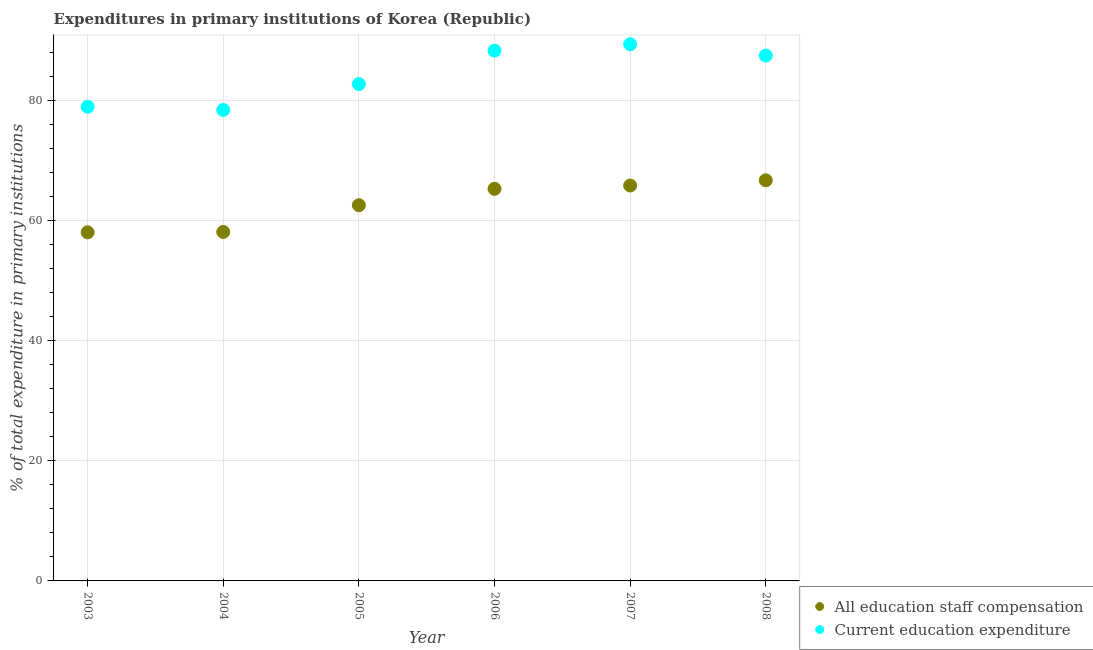What is the expenditure in education in 2006?
Your answer should be compact. 88.3. Across all years, what is the maximum expenditure in staff compensation?
Make the answer very short. 66.71. Across all years, what is the minimum expenditure in education?
Give a very brief answer. 78.43. In which year was the expenditure in staff compensation maximum?
Ensure brevity in your answer.  2008. What is the total expenditure in staff compensation in the graph?
Give a very brief answer. 376.55. What is the difference between the expenditure in staff compensation in 2005 and that in 2008?
Make the answer very short. -4.15. What is the difference between the expenditure in staff compensation in 2005 and the expenditure in education in 2008?
Give a very brief answer. -24.93. What is the average expenditure in staff compensation per year?
Ensure brevity in your answer.  62.76. In the year 2008, what is the difference between the expenditure in education and expenditure in staff compensation?
Your answer should be compact. 20.78. In how many years, is the expenditure in staff compensation greater than 12 %?
Offer a terse response. 6. What is the ratio of the expenditure in education in 2004 to that in 2007?
Your answer should be compact. 0.88. Is the expenditure in staff compensation in 2007 less than that in 2008?
Ensure brevity in your answer.  Yes. What is the difference between the highest and the second highest expenditure in staff compensation?
Provide a short and direct response. 0.87. What is the difference between the highest and the lowest expenditure in staff compensation?
Offer a terse response. 8.66. In how many years, is the expenditure in education greater than the average expenditure in education taken over all years?
Your answer should be very brief. 3. How many years are there in the graph?
Your answer should be very brief. 6. Does the graph contain any zero values?
Keep it short and to the point. No. How many legend labels are there?
Provide a succinct answer. 2. How are the legend labels stacked?
Your answer should be compact. Vertical. What is the title of the graph?
Offer a very short reply. Expenditures in primary institutions of Korea (Republic). What is the label or title of the X-axis?
Provide a short and direct response. Year. What is the label or title of the Y-axis?
Offer a very short reply. % of total expenditure in primary institutions. What is the % of total expenditure in primary institutions in All education staff compensation in 2003?
Your response must be concise. 58.05. What is the % of total expenditure in primary institutions of Current education expenditure in 2003?
Provide a succinct answer. 78.96. What is the % of total expenditure in primary institutions of All education staff compensation in 2004?
Your answer should be very brief. 58.11. What is the % of total expenditure in primary institutions in Current education expenditure in 2004?
Provide a succinct answer. 78.43. What is the % of total expenditure in primary institutions in All education staff compensation in 2005?
Offer a very short reply. 62.56. What is the % of total expenditure in primary institutions of Current education expenditure in 2005?
Your answer should be compact. 82.73. What is the % of total expenditure in primary institutions in All education staff compensation in 2006?
Your response must be concise. 65.29. What is the % of total expenditure in primary institutions in Current education expenditure in 2006?
Ensure brevity in your answer.  88.3. What is the % of total expenditure in primary institutions in All education staff compensation in 2007?
Ensure brevity in your answer.  65.84. What is the % of total expenditure in primary institutions of Current education expenditure in 2007?
Your answer should be very brief. 89.36. What is the % of total expenditure in primary institutions of All education staff compensation in 2008?
Provide a short and direct response. 66.71. What is the % of total expenditure in primary institutions of Current education expenditure in 2008?
Your answer should be very brief. 87.49. Across all years, what is the maximum % of total expenditure in primary institutions in All education staff compensation?
Your answer should be very brief. 66.71. Across all years, what is the maximum % of total expenditure in primary institutions in Current education expenditure?
Offer a very short reply. 89.36. Across all years, what is the minimum % of total expenditure in primary institutions in All education staff compensation?
Give a very brief answer. 58.05. Across all years, what is the minimum % of total expenditure in primary institutions of Current education expenditure?
Offer a terse response. 78.43. What is the total % of total expenditure in primary institutions in All education staff compensation in the graph?
Provide a succinct answer. 376.55. What is the total % of total expenditure in primary institutions in Current education expenditure in the graph?
Offer a terse response. 505.28. What is the difference between the % of total expenditure in primary institutions in All education staff compensation in 2003 and that in 2004?
Your answer should be compact. -0.06. What is the difference between the % of total expenditure in primary institutions of Current education expenditure in 2003 and that in 2004?
Make the answer very short. 0.53. What is the difference between the % of total expenditure in primary institutions of All education staff compensation in 2003 and that in 2005?
Provide a short and direct response. -4.51. What is the difference between the % of total expenditure in primary institutions in Current education expenditure in 2003 and that in 2005?
Offer a very short reply. -3.77. What is the difference between the % of total expenditure in primary institutions of All education staff compensation in 2003 and that in 2006?
Offer a terse response. -7.24. What is the difference between the % of total expenditure in primary institutions of Current education expenditure in 2003 and that in 2006?
Offer a very short reply. -9.34. What is the difference between the % of total expenditure in primary institutions in All education staff compensation in 2003 and that in 2007?
Provide a short and direct response. -7.79. What is the difference between the % of total expenditure in primary institutions of Current education expenditure in 2003 and that in 2007?
Give a very brief answer. -10.4. What is the difference between the % of total expenditure in primary institutions of All education staff compensation in 2003 and that in 2008?
Provide a short and direct response. -8.66. What is the difference between the % of total expenditure in primary institutions in Current education expenditure in 2003 and that in 2008?
Provide a short and direct response. -8.52. What is the difference between the % of total expenditure in primary institutions of All education staff compensation in 2004 and that in 2005?
Keep it short and to the point. -4.45. What is the difference between the % of total expenditure in primary institutions of Current education expenditure in 2004 and that in 2005?
Offer a terse response. -4.3. What is the difference between the % of total expenditure in primary institutions of All education staff compensation in 2004 and that in 2006?
Ensure brevity in your answer.  -7.18. What is the difference between the % of total expenditure in primary institutions of Current education expenditure in 2004 and that in 2006?
Offer a terse response. -9.87. What is the difference between the % of total expenditure in primary institutions in All education staff compensation in 2004 and that in 2007?
Give a very brief answer. -7.73. What is the difference between the % of total expenditure in primary institutions of Current education expenditure in 2004 and that in 2007?
Offer a very short reply. -10.93. What is the difference between the % of total expenditure in primary institutions of All education staff compensation in 2004 and that in 2008?
Your answer should be compact. -8.6. What is the difference between the % of total expenditure in primary institutions in Current education expenditure in 2004 and that in 2008?
Your answer should be very brief. -9.05. What is the difference between the % of total expenditure in primary institutions in All education staff compensation in 2005 and that in 2006?
Provide a succinct answer. -2.73. What is the difference between the % of total expenditure in primary institutions of Current education expenditure in 2005 and that in 2006?
Keep it short and to the point. -5.57. What is the difference between the % of total expenditure in primary institutions of All education staff compensation in 2005 and that in 2007?
Provide a short and direct response. -3.28. What is the difference between the % of total expenditure in primary institutions in Current education expenditure in 2005 and that in 2007?
Offer a terse response. -6.62. What is the difference between the % of total expenditure in primary institutions in All education staff compensation in 2005 and that in 2008?
Provide a short and direct response. -4.15. What is the difference between the % of total expenditure in primary institutions of Current education expenditure in 2005 and that in 2008?
Ensure brevity in your answer.  -4.75. What is the difference between the % of total expenditure in primary institutions in All education staff compensation in 2006 and that in 2007?
Give a very brief answer. -0.55. What is the difference between the % of total expenditure in primary institutions in Current education expenditure in 2006 and that in 2007?
Offer a very short reply. -1.06. What is the difference between the % of total expenditure in primary institutions of All education staff compensation in 2006 and that in 2008?
Your answer should be very brief. -1.42. What is the difference between the % of total expenditure in primary institutions of Current education expenditure in 2006 and that in 2008?
Offer a terse response. 0.82. What is the difference between the % of total expenditure in primary institutions in All education staff compensation in 2007 and that in 2008?
Offer a very short reply. -0.87. What is the difference between the % of total expenditure in primary institutions in Current education expenditure in 2007 and that in 2008?
Your answer should be compact. 1.87. What is the difference between the % of total expenditure in primary institutions of All education staff compensation in 2003 and the % of total expenditure in primary institutions of Current education expenditure in 2004?
Offer a terse response. -20.39. What is the difference between the % of total expenditure in primary institutions of All education staff compensation in 2003 and the % of total expenditure in primary institutions of Current education expenditure in 2005?
Give a very brief answer. -24.69. What is the difference between the % of total expenditure in primary institutions in All education staff compensation in 2003 and the % of total expenditure in primary institutions in Current education expenditure in 2006?
Make the answer very short. -30.25. What is the difference between the % of total expenditure in primary institutions in All education staff compensation in 2003 and the % of total expenditure in primary institutions in Current education expenditure in 2007?
Provide a short and direct response. -31.31. What is the difference between the % of total expenditure in primary institutions in All education staff compensation in 2003 and the % of total expenditure in primary institutions in Current education expenditure in 2008?
Keep it short and to the point. -29.44. What is the difference between the % of total expenditure in primary institutions in All education staff compensation in 2004 and the % of total expenditure in primary institutions in Current education expenditure in 2005?
Provide a succinct answer. -24.63. What is the difference between the % of total expenditure in primary institutions of All education staff compensation in 2004 and the % of total expenditure in primary institutions of Current education expenditure in 2006?
Keep it short and to the point. -30.2. What is the difference between the % of total expenditure in primary institutions of All education staff compensation in 2004 and the % of total expenditure in primary institutions of Current education expenditure in 2007?
Provide a succinct answer. -31.25. What is the difference between the % of total expenditure in primary institutions in All education staff compensation in 2004 and the % of total expenditure in primary institutions in Current education expenditure in 2008?
Provide a succinct answer. -29.38. What is the difference between the % of total expenditure in primary institutions of All education staff compensation in 2005 and the % of total expenditure in primary institutions of Current education expenditure in 2006?
Your answer should be compact. -25.74. What is the difference between the % of total expenditure in primary institutions in All education staff compensation in 2005 and the % of total expenditure in primary institutions in Current education expenditure in 2007?
Keep it short and to the point. -26.8. What is the difference between the % of total expenditure in primary institutions in All education staff compensation in 2005 and the % of total expenditure in primary institutions in Current education expenditure in 2008?
Offer a terse response. -24.93. What is the difference between the % of total expenditure in primary institutions in All education staff compensation in 2006 and the % of total expenditure in primary institutions in Current education expenditure in 2007?
Ensure brevity in your answer.  -24.07. What is the difference between the % of total expenditure in primary institutions of All education staff compensation in 2006 and the % of total expenditure in primary institutions of Current education expenditure in 2008?
Offer a terse response. -22.2. What is the difference between the % of total expenditure in primary institutions of All education staff compensation in 2007 and the % of total expenditure in primary institutions of Current education expenditure in 2008?
Give a very brief answer. -21.65. What is the average % of total expenditure in primary institutions of All education staff compensation per year?
Provide a short and direct response. 62.76. What is the average % of total expenditure in primary institutions in Current education expenditure per year?
Offer a very short reply. 84.21. In the year 2003, what is the difference between the % of total expenditure in primary institutions in All education staff compensation and % of total expenditure in primary institutions in Current education expenditure?
Your answer should be very brief. -20.91. In the year 2004, what is the difference between the % of total expenditure in primary institutions of All education staff compensation and % of total expenditure in primary institutions of Current education expenditure?
Your answer should be very brief. -20.33. In the year 2005, what is the difference between the % of total expenditure in primary institutions of All education staff compensation and % of total expenditure in primary institutions of Current education expenditure?
Keep it short and to the point. -20.18. In the year 2006, what is the difference between the % of total expenditure in primary institutions of All education staff compensation and % of total expenditure in primary institutions of Current education expenditure?
Ensure brevity in your answer.  -23.01. In the year 2007, what is the difference between the % of total expenditure in primary institutions of All education staff compensation and % of total expenditure in primary institutions of Current education expenditure?
Offer a very short reply. -23.52. In the year 2008, what is the difference between the % of total expenditure in primary institutions in All education staff compensation and % of total expenditure in primary institutions in Current education expenditure?
Ensure brevity in your answer.  -20.78. What is the ratio of the % of total expenditure in primary institutions in Current education expenditure in 2003 to that in 2004?
Give a very brief answer. 1.01. What is the ratio of the % of total expenditure in primary institutions in All education staff compensation in 2003 to that in 2005?
Offer a terse response. 0.93. What is the ratio of the % of total expenditure in primary institutions in Current education expenditure in 2003 to that in 2005?
Keep it short and to the point. 0.95. What is the ratio of the % of total expenditure in primary institutions in All education staff compensation in 2003 to that in 2006?
Provide a short and direct response. 0.89. What is the ratio of the % of total expenditure in primary institutions of Current education expenditure in 2003 to that in 2006?
Your answer should be compact. 0.89. What is the ratio of the % of total expenditure in primary institutions in All education staff compensation in 2003 to that in 2007?
Your answer should be compact. 0.88. What is the ratio of the % of total expenditure in primary institutions of Current education expenditure in 2003 to that in 2007?
Provide a succinct answer. 0.88. What is the ratio of the % of total expenditure in primary institutions of All education staff compensation in 2003 to that in 2008?
Make the answer very short. 0.87. What is the ratio of the % of total expenditure in primary institutions of Current education expenditure in 2003 to that in 2008?
Your answer should be very brief. 0.9. What is the ratio of the % of total expenditure in primary institutions of All education staff compensation in 2004 to that in 2005?
Your answer should be compact. 0.93. What is the ratio of the % of total expenditure in primary institutions of Current education expenditure in 2004 to that in 2005?
Your answer should be very brief. 0.95. What is the ratio of the % of total expenditure in primary institutions in All education staff compensation in 2004 to that in 2006?
Provide a short and direct response. 0.89. What is the ratio of the % of total expenditure in primary institutions in Current education expenditure in 2004 to that in 2006?
Provide a short and direct response. 0.89. What is the ratio of the % of total expenditure in primary institutions in All education staff compensation in 2004 to that in 2007?
Your response must be concise. 0.88. What is the ratio of the % of total expenditure in primary institutions of Current education expenditure in 2004 to that in 2007?
Give a very brief answer. 0.88. What is the ratio of the % of total expenditure in primary institutions of All education staff compensation in 2004 to that in 2008?
Give a very brief answer. 0.87. What is the ratio of the % of total expenditure in primary institutions of Current education expenditure in 2004 to that in 2008?
Provide a succinct answer. 0.9. What is the ratio of the % of total expenditure in primary institutions of All education staff compensation in 2005 to that in 2006?
Your answer should be compact. 0.96. What is the ratio of the % of total expenditure in primary institutions of Current education expenditure in 2005 to that in 2006?
Your answer should be compact. 0.94. What is the ratio of the % of total expenditure in primary institutions in All education staff compensation in 2005 to that in 2007?
Offer a terse response. 0.95. What is the ratio of the % of total expenditure in primary institutions in Current education expenditure in 2005 to that in 2007?
Provide a succinct answer. 0.93. What is the ratio of the % of total expenditure in primary institutions in All education staff compensation in 2005 to that in 2008?
Make the answer very short. 0.94. What is the ratio of the % of total expenditure in primary institutions in Current education expenditure in 2005 to that in 2008?
Offer a very short reply. 0.95. What is the ratio of the % of total expenditure in primary institutions of All education staff compensation in 2006 to that in 2007?
Keep it short and to the point. 0.99. What is the ratio of the % of total expenditure in primary institutions of All education staff compensation in 2006 to that in 2008?
Your answer should be very brief. 0.98. What is the ratio of the % of total expenditure in primary institutions of Current education expenditure in 2006 to that in 2008?
Offer a very short reply. 1.01. What is the ratio of the % of total expenditure in primary institutions in Current education expenditure in 2007 to that in 2008?
Your answer should be compact. 1.02. What is the difference between the highest and the second highest % of total expenditure in primary institutions of All education staff compensation?
Provide a succinct answer. 0.87. What is the difference between the highest and the second highest % of total expenditure in primary institutions in Current education expenditure?
Your response must be concise. 1.06. What is the difference between the highest and the lowest % of total expenditure in primary institutions of All education staff compensation?
Keep it short and to the point. 8.66. What is the difference between the highest and the lowest % of total expenditure in primary institutions in Current education expenditure?
Keep it short and to the point. 10.93. 